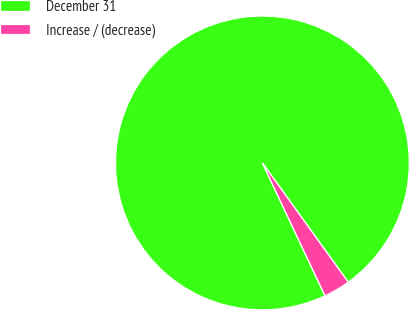Convert chart. <chart><loc_0><loc_0><loc_500><loc_500><pie_chart><fcel>December 31<fcel>Increase / (decrease)<nl><fcel>97.08%<fcel>2.92%<nl></chart> 